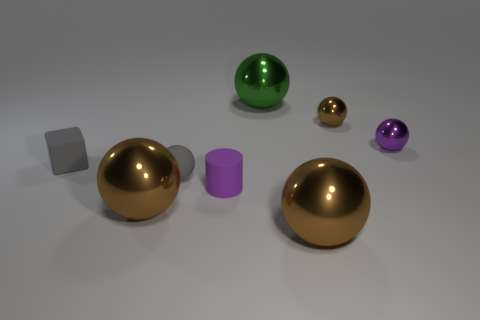There is a brown thing that is behind the small cube; does it have the same size as the purple sphere to the right of the small gray cube?
Give a very brief answer. Yes. Is the tiny cylinder made of the same material as the gray thing behind the matte sphere?
Give a very brief answer. Yes. Is the number of big things in front of the small cylinder greater than the number of tiny cylinders behind the block?
Make the answer very short. Yes. What is the color of the tiny ball that is in front of the tiny ball that is on the right side of the tiny brown sphere?
Your response must be concise. Gray. How many spheres are either matte things or small shiny things?
Offer a very short reply. 3. What number of things are in front of the purple cylinder and to the left of the purple cylinder?
Your response must be concise. 1. The big sphere that is left of the green metallic thing is what color?
Keep it short and to the point. Brown. There is a green thing that is the same material as the purple ball; what size is it?
Make the answer very short. Large. What number of purple metal things are in front of the large thing to the right of the green metal object?
Offer a very short reply. 0. How many green shiny balls are on the left side of the large green metal ball?
Keep it short and to the point. 0. 